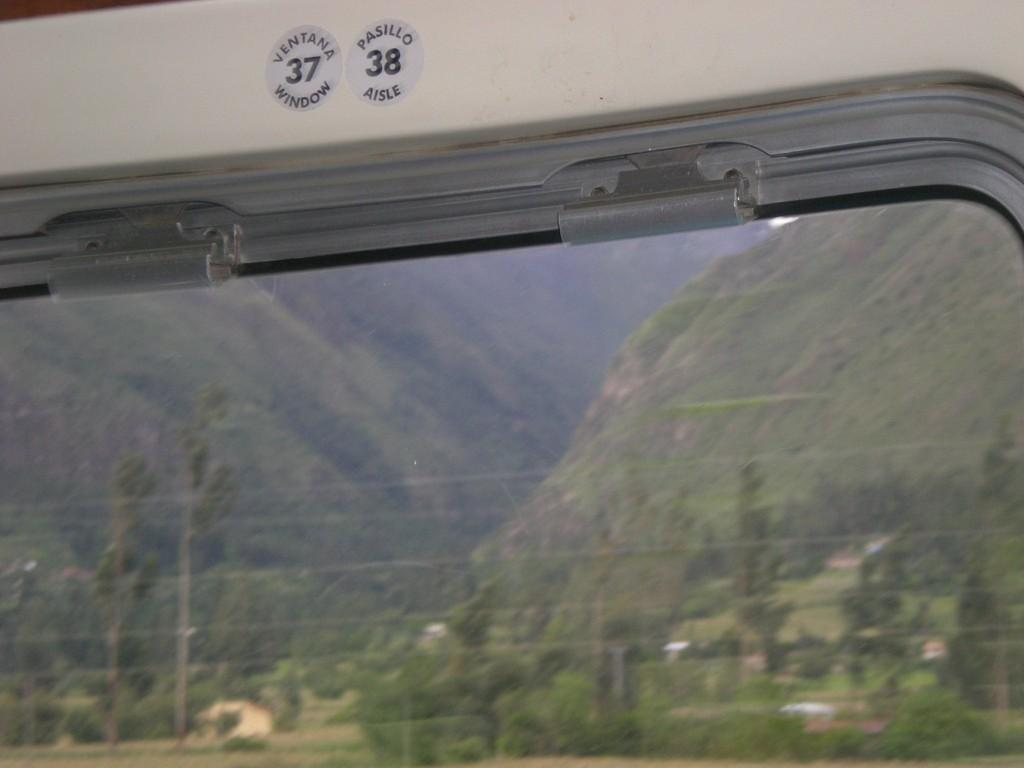What type of structure is present in the image? There is a glass window in the image. What can be seen on the glass window? The glass window has numbers on it. What natural features are visible in the background of the image? Mountains and a group of trees are visible in the background of the image. Where is the turkey located in the image? There is no turkey present in the image. What type of pin is holding the cub's fur in place in the image? There is no cub or pin present in the image. 